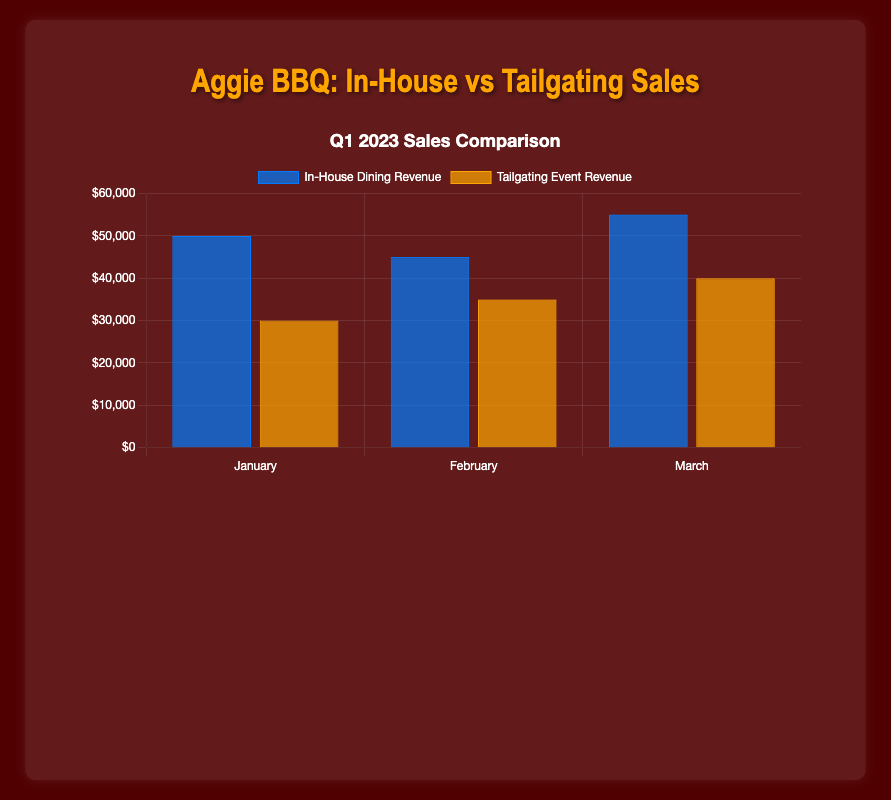Which month had the highest in-house dining revenue? The figure shows bar heights for in-house dining revenue across January, February, and March. The tallest bar under in-house dining corresponds to March.
Answer: March What is the total revenue from tailgating events over the first quarter? To calculate the total revenue from tailgating events, sum the revenues for January, February, and March: 30,000 + 35,000 + 40,000 = 105,000.
Answer: $105,000 How much more was spent on in-house dining compared to tailgating events in March? Subtract the tailgating revenue from the in-house dining revenue in March: 55,000 - 40,000 = 15,000.
Answer: $15,000 Which category had higher revenue in February and by how much? Compare the revenue bars for February in both categories: in-house dining (45,000) and tailgating events (35,000). The in-house dining revenue is higher. Subtract the lower value from the higher value: 45,000 - 35,000 = 10,000.
Answer: In-house dining by $10,000 In which month was the gap between in-house dining and tailgating revenue the smallest? Compare the differences between in-house dining and tailgating revenues for each month: 
- January: 50,000 - 30,000 = 20,000
- February: 45,000 - 35,000 = 10,000
- March: 55,000 - 40,000 = 15,000
The smallest gap is in February.
Answer: February What is the average in-house dining revenue for the first quarter? To find the average, sum the in-house dining revenues and divide by the number of months: (50,000 + 45,000 + 55,000) / 3 = 150,000 / 3 = 50,000.
Answer: $50,000 Which category showed a steady increase in revenue over the three months? Compare the month-on-month revenue for both categories: 
- In-house dining: Jan: 50,000 → Feb: 45,000 → Mar: 55,000 (not steady)
- Tailgating events: Jan: 30,000 → Feb: 35,000 → Mar: 40,000 (steady increase)
Only tailgating events showed steady growth.
Answer: Tailgating events What percentage of the total Q1 revenue (in-house and tailgating combined) came from in-house dining? First, calculate total Q1 revenue: (50,000 + 45,000 + 55,000) + (30,000 + 35,000 + 40,000) = 150,000 + 105,000 = 255,000. Then calculate the percentage from in-house dining: (150,000 / 255,000) * 100 ≈ 58.82%.
Answer: Approximately 58.82% 